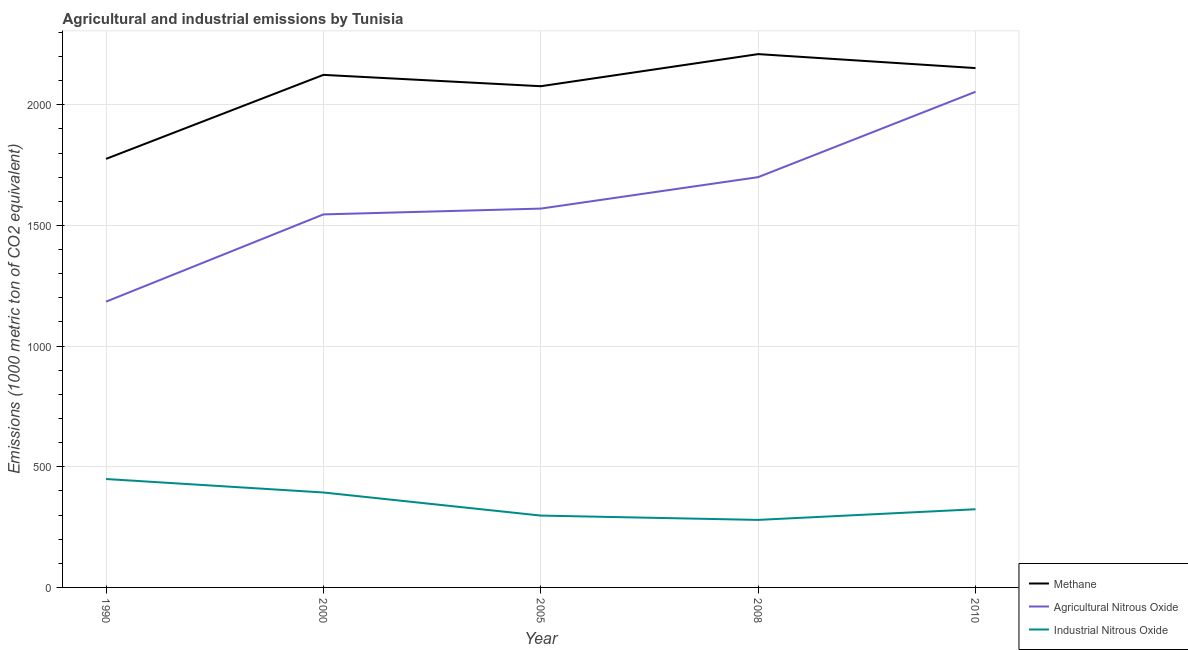How many different coloured lines are there?
Your response must be concise. 3. Is the number of lines equal to the number of legend labels?
Your response must be concise. Yes. What is the amount of agricultural nitrous oxide emissions in 2010?
Offer a terse response. 2053.7. Across all years, what is the maximum amount of industrial nitrous oxide emissions?
Your response must be concise. 449.2. Across all years, what is the minimum amount of methane emissions?
Your response must be concise. 1775.7. What is the total amount of industrial nitrous oxide emissions in the graph?
Give a very brief answer. 1744. What is the difference between the amount of industrial nitrous oxide emissions in 1990 and that in 2008?
Your answer should be very brief. 169.4. What is the difference between the amount of methane emissions in 2008 and the amount of industrial nitrous oxide emissions in 2005?
Make the answer very short. 1912.1. What is the average amount of agricultural nitrous oxide emissions per year?
Offer a terse response. 1610.62. In the year 2000, what is the difference between the amount of agricultural nitrous oxide emissions and amount of industrial nitrous oxide emissions?
Provide a short and direct response. 1152.2. In how many years, is the amount of methane emissions greater than 1400 metric ton?
Ensure brevity in your answer.  5. What is the ratio of the amount of industrial nitrous oxide emissions in 1990 to that in 2008?
Provide a short and direct response. 1.61. What is the difference between the highest and the second highest amount of agricultural nitrous oxide emissions?
Give a very brief answer. 353.7. What is the difference between the highest and the lowest amount of methane emissions?
Your response must be concise. 434.1. In how many years, is the amount of industrial nitrous oxide emissions greater than the average amount of industrial nitrous oxide emissions taken over all years?
Give a very brief answer. 2. Is it the case that in every year, the sum of the amount of methane emissions and amount of agricultural nitrous oxide emissions is greater than the amount of industrial nitrous oxide emissions?
Give a very brief answer. Yes. Does the amount of methane emissions monotonically increase over the years?
Make the answer very short. No. Is the amount of methane emissions strictly less than the amount of agricultural nitrous oxide emissions over the years?
Your answer should be very brief. No. What is the difference between two consecutive major ticks on the Y-axis?
Provide a succinct answer. 500. Does the graph contain grids?
Your answer should be compact. Yes. Where does the legend appear in the graph?
Keep it short and to the point. Bottom right. What is the title of the graph?
Offer a very short reply. Agricultural and industrial emissions by Tunisia. What is the label or title of the X-axis?
Your answer should be very brief. Year. What is the label or title of the Y-axis?
Provide a short and direct response. Emissions (1000 metric ton of CO2 equivalent). What is the Emissions (1000 metric ton of CO2 equivalent) of Methane in 1990?
Provide a short and direct response. 1775.7. What is the Emissions (1000 metric ton of CO2 equivalent) of Agricultural Nitrous Oxide in 1990?
Your answer should be very brief. 1184.1. What is the Emissions (1000 metric ton of CO2 equivalent) of Industrial Nitrous Oxide in 1990?
Provide a short and direct response. 449.2. What is the Emissions (1000 metric ton of CO2 equivalent) in Methane in 2000?
Make the answer very short. 2123.8. What is the Emissions (1000 metric ton of CO2 equivalent) in Agricultural Nitrous Oxide in 2000?
Your answer should be very brief. 1545.6. What is the Emissions (1000 metric ton of CO2 equivalent) in Industrial Nitrous Oxide in 2000?
Offer a very short reply. 393.4. What is the Emissions (1000 metric ton of CO2 equivalent) in Methane in 2005?
Your answer should be very brief. 2076.8. What is the Emissions (1000 metric ton of CO2 equivalent) in Agricultural Nitrous Oxide in 2005?
Offer a terse response. 1569.7. What is the Emissions (1000 metric ton of CO2 equivalent) in Industrial Nitrous Oxide in 2005?
Your answer should be very brief. 297.7. What is the Emissions (1000 metric ton of CO2 equivalent) of Methane in 2008?
Offer a very short reply. 2209.8. What is the Emissions (1000 metric ton of CO2 equivalent) of Agricultural Nitrous Oxide in 2008?
Your answer should be compact. 1700. What is the Emissions (1000 metric ton of CO2 equivalent) of Industrial Nitrous Oxide in 2008?
Give a very brief answer. 279.8. What is the Emissions (1000 metric ton of CO2 equivalent) of Methane in 2010?
Ensure brevity in your answer.  2151.9. What is the Emissions (1000 metric ton of CO2 equivalent) in Agricultural Nitrous Oxide in 2010?
Make the answer very short. 2053.7. What is the Emissions (1000 metric ton of CO2 equivalent) in Industrial Nitrous Oxide in 2010?
Make the answer very short. 323.9. Across all years, what is the maximum Emissions (1000 metric ton of CO2 equivalent) of Methane?
Your response must be concise. 2209.8. Across all years, what is the maximum Emissions (1000 metric ton of CO2 equivalent) of Agricultural Nitrous Oxide?
Make the answer very short. 2053.7. Across all years, what is the maximum Emissions (1000 metric ton of CO2 equivalent) in Industrial Nitrous Oxide?
Offer a terse response. 449.2. Across all years, what is the minimum Emissions (1000 metric ton of CO2 equivalent) of Methane?
Offer a terse response. 1775.7. Across all years, what is the minimum Emissions (1000 metric ton of CO2 equivalent) in Agricultural Nitrous Oxide?
Your answer should be compact. 1184.1. Across all years, what is the minimum Emissions (1000 metric ton of CO2 equivalent) in Industrial Nitrous Oxide?
Keep it short and to the point. 279.8. What is the total Emissions (1000 metric ton of CO2 equivalent) in Methane in the graph?
Ensure brevity in your answer.  1.03e+04. What is the total Emissions (1000 metric ton of CO2 equivalent) of Agricultural Nitrous Oxide in the graph?
Provide a short and direct response. 8053.1. What is the total Emissions (1000 metric ton of CO2 equivalent) in Industrial Nitrous Oxide in the graph?
Offer a very short reply. 1744. What is the difference between the Emissions (1000 metric ton of CO2 equivalent) in Methane in 1990 and that in 2000?
Your response must be concise. -348.1. What is the difference between the Emissions (1000 metric ton of CO2 equivalent) of Agricultural Nitrous Oxide in 1990 and that in 2000?
Your response must be concise. -361.5. What is the difference between the Emissions (1000 metric ton of CO2 equivalent) of Industrial Nitrous Oxide in 1990 and that in 2000?
Ensure brevity in your answer.  55.8. What is the difference between the Emissions (1000 metric ton of CO2 equivalent) of Methane in 1990 and that in 2005?
Give a very brief answer. -301.1. What is the difference between the Emissions (1000 metric ton of CO2 equivalent) in Agricultural Nitrous Oxide in 1990 and that in 2005?
Your answer should be compact. -385.6. What is the difference between the Emissions (1000 metric ton of CO2 equivalent) of Industrial Nitrous Oxide in 1990 and that in 2005?
Your answer should be very brief. 151.5. What is the difference between the Emissions (1000 metric ton of CO2 equivalent) in Methane in 1990 and that in 2008?
Your answer should be very brief. -434.1. What is the difference between the Emissions (1000 metric ton of CO2 equivalent) of Agricultural Nitrous Oxide in 1990 and that in 2008?
Give a very brief answer. -515.9. What is the difference between the Emissions (1000 metric ton of CO2 equivalent) of Industrial Nitrous Oxide in 1990 and that in 2008?
Keep it short and to the point. 169.4. What is the difference between the Emissions (1000 metric ton of CO2 equivalent) in Methane in 1990 and that in 2010?
Keep it short and to the point. -376.2. What is the difference between the Emissions (1000 metric ton of CO2 equivalent) in Agricultural Nitrous Oxide in 1990 and that in 2010?
Provide a short and direct response. -869.6. What is the difference between the Emissions (1000 metric ton of CO2 equivalent) in Industrial Nitrous Oxide in 1990 and that in 2010?
Your answer should be very brief. 125.3. What is the difference between the Emissions (1000 metric ton of CO2 equivalent) in Methane in 2000 and that in 2005?
Your response must be concise. 47. What is the difference between the Emissions (1000 metric ton of CO2 equivalent) in Agricultural Nitrous Oxide in 2000 and that in 2005?
Offer a very short reply. -24.1. What is the difference between the Emissions (1000 metric ton of CO2 equivalent) in Industrial Nitrous Oxide in 2000 and that in 2005?
Ensure brevity in your answer.  95.7. What is the difference between the Emissions (1000 metric ton of CO2 equivalent) in Methane in 2000 and that in 2008?
Ensure brevity in your answer.  -86. What is the difference between the Emissions (1000 metric ton of CO2 equivalent) in Agricultural Nitrous Oxide in 2000 and that in 2008?
Keep it short and to the point. -154.4. What is the difference between the Emissions (1000 metric ton of CO2 equivalent) in Industrial Nitrous Oxide in 2000 and that in 2008?
Your response must be concise. 113.6. What is the difference between the Emissions (1000 metric ton of CO2 equivalent) of Methane in 2000 and that in 2010?
Give a very brief answer. -28.1. What is the difference between the Emissions (1000 metric ton of CO2 equivalent) in Agricultural Nitrous Oxide in 2000 and that in 2010?
Give a very brief answer. -508.1. What is the difference between the Emissions (1000 metric ton of CO2 equivalent) of Industrial Nitrous Oxide in 2000 and that in 2010?
Make the answer very short. 69.5. What is the difference between the Emissions (1000 metric ton of CO2 equivalent) in Methane in 2005 and that in 2008?
Your response must be concise. -133. What is the difference between the Emissions (1000 metric ton of CO2 equivalent) of Agricultural Nitrous Oxide in 2005 and that in 2008?
Your response must be concise. -130.3. What is the difference between the Emissions (1000 metric ton of CO2 equivalent) of Industrial Nitrous Oxide in 2005 and that in 2008?
Your answer should be compact. 17.9. What is the difference between the Emissions (1000 metric ton of CO2 equivalent) in Methane in 2005 and that in 2010?
Keep it short and to the point. -75.1. What is the difference between the Emissions (1000 metric ton of CO2 equivalent) of Agricultural Nitrous Oxide in 2005 and that in 2010?
Keep it short and to the point. -484. What is the difference between the Emissions (1000 metric ton of CO2 equivalent) of Industrial Nitrous Oxide in 2005 and that in 2010?
Keep it short and to the point. -26.2. What is the difference between the Emissions (1000 metric ton of CO2 equivalent) in Methane in 2008 and that in 2010?
Keep it short and to the point. 57.9. What is the difference between the Emissions (1000 metric ton of CO2 equivalent) of Agricultural Nitrous Oxide in 2008 and that in 2010?
Keep it short and to the point. -353.7. What is the difference between the Emissions (1000 metric ton of CO2 equivalent) of Industrial Nitrous Oxide in 2008 and that in 2010?
Provide a short and direct response. -44.1. What is the difference between the Emissions (1000 metric ton of CO2 equivalent) of Methane in 1990 and the Emissions (1000 metric ton of CO2 equivalent) of Agricultural Nitrous Oxide in 2000?
Give a very brief answer. 230.1. What is the difference between the Emissions (1000 metric ton of CO2 equivalent) of Methane in 1990 and the Emissions (1000 metric ton of CO2 equivalent) of Industrial Nitrous Oxide in 2000?
Offer a terse response. 1382.3. What is the difference between the Emissions (1000 metric ton of CO2 equivalent) in Agricultural Nitrous Oxide in 1990 and the Emissions (1000 metric ton of CO2 equivalent) in Industrial Nitrous Oxide in 2000?
Your response must be concise. 790.7. What is the difference between the Emissions (1000 metric ton of CO2 equivalent) in Methane in 1990 and the Emissions (1000 metric ton of CO2 equivalent) in Agricultural Nitrous Oxide in 2005?
Your answer should be compact. 206. What is the difference between the Emissions (1000 metric ton of CO2 equivalent) in Methane in 1990 and the Emissions (1000 metric ton of CO2 equivalent) in Industrial Nitrous Oxide in 2005?
Ensure brevity in your answer.  1478. What is the difference between the Emissions (1000 metric ton of CO2 equivalent) of Agricultural Nitrous Oxide in 1990 and the Emissions (1000 metric ton of CO2 equivalent) of Industrial Nitrous Oxide in 2005?
Offer a terse response. 886.4. What is the difference between the Emissions (1000 metric ton of CO2 equivalent) of Methane in 1990 and the Emissions (1000 metric ton of CO2 equivalent) of Agricultural Nitrous Oxide in 2008?
Ensure brevity in your answer.  75.7. What is the difference between the Emissions (1000 metric ton of CO2 equivalent) of Methane in 1990 and the Emissions (1000 metric ton of CO2 equivalent) of Industrial Nitrous Oxide in 2008?
Provide a succinct answer. 1495.9. What is the difference between the Emissions (1000 metric ton of CO2 equivalent) in Agricultural Nitrous Oxide in 1990 and the Emissions (1000 metric ton of CO2 equivalent) in Industrial Nitrous Oxide in 2008?
Your answer should be compact. 904.3. What is the difference between the Emissions (1000 metric ton of CO2 equivalent) of Methane in 1990 and the Emissions (1000 metric ton of CO2 equivalent) of Agricultural Nitrous Oxide in 2010?
Make the answer very short. -278. What is the difference between the Emissions (1000 metric ton of CO2 equivalent) in Methane in 1990 and the Emissions (1000 metric ton of CO2 equivalent) in Industrial Nitrous Oxide in 2010?
Offer a very short reply. 1451.8. What is the difference between the Emissions (1000 metric ton of CO2 equivalent) of Agricultural Nitrous Oxide in 1990 and the Emissions (1000 metric ton of CO2 equivalent) of Industrial Nitrous Oxide in 2010?
Provide a short and direct response. 860.2. What is the difference between the Emissions (1000 metric ton of CO2 equivalent) of Methane in 2000 and the Emissions (1000 metric ton of CO2 equivalent) of Agricultural Nitrous Oxide in 2005?
Your response must be concise. 554.1. What is the difference between the Emissions (1000 metric ton of CO2 equivalent) of Methane in 2000 and the Emissions (1000 metric ton of CO2 equivalent) of Industrial Nitrous Oxide in 2005?
Your response must be concise. 1826.1. What is the difference between the Emissions (1000 metric ton of CO2 equivalent) in Agricultural Nitrous Oxide in 2000 and the Emissions (1000 metric ton of CO2 equivalent) in Industrial Nitrous Oxide in 2005?
Offer a very short reply. 1247.9. What is the difference between the Emissions (1000 metric ton of CO2 equivalent) of Methane in 2000 and the Emissions (1000 metric ton of CO2 equivalent) of Agricultural Nitrous Oxide in 2008?
Your response must be concise. 423.8. What is the difference between the Emissions (1000 metric ton of CO2 equivalent) of Methane in 2000 and the Emissions (1000 metric ton of CO2 equivalent) of Industrial Nitrous Oxide in 2008?
Keep it short and to the point. 1844. What is the difference between the Emissions (1000 metric ton of CO2 equivalent) in Agricultural Nitrous Oxide in 2000 and the Emissions (1000 metric ton of CO2 equivalent) in Industrial Nitrous Oxide in 2008?
Provide a short and direct response. 1265.8. What is the difference between the Emissions (1000 metric ton of CO2 equivalent) of Methane in 2000 and the Emissions (1000 metric ton of CO2 equivalent) of Agricultural Nitrous Oxide in 2010?
Keep it short and to the point. 70.1. What is the difference between the Emissions (1000 metric ton of CO2 equivalent) in Methane in 2000 and the Emissions (1000 metric ton of CO2 equivalent) in Industrial Nitrous Oxide in 2010?
Provide a short and direct response. 1799.9. What is the difference between the Emissions (1000 metric ton of CO2 equivalent) in Agricultural Nitrous Oxide in 2000 and the Emissions (1000 metric ton of CO2 equivalent) in Industrial Nitrous Oxide in 2010?
Provide a succinct answer. 1221.7. What is the difference between the Emissions (1000 metric ton of CO2 equivalent) of Methane in 2005 and the Emissions (1000 metric ton of CO2 equivalent) of Agricultural Nitrous Oxide in 2008?
Provide a short and direct response. 376.8. What is the difference between the Emissions (1000 metric ton of CO2 equivalent) in Methane in 2005 and the Emissions (1000 metric ton of CO2 equivalent) in Industrial Nitrous Oxide in 2008?
Make the answer very short. 1797. What is the difference between the Emissions (1000 metric ton of CO2 equivalent) in Agricultural Nitrous Oxide in 2005 and the Emissions (1000 metric ton of CO2 equivalent) in Industrial Nitrous Oxide in 2008?
Your answer should be compact. 1289.9. What is the difference between the Emissions (1000 metric ton of CO2 equivalent) in Methane in 2005 and the Emissions (1000 metric ton of CO2 equivalent) in Agricultural Nitrous Oxide in 2010?
Make the answer very short. 23.1. What is the difference between the Emissions (1000 metric ton of CO2 equivalent) of Methane in 2005 and the Emissions (1000 metric ton of CO2 equivalent) of Industrial Nitrous Oxide in 2010?
Give a very brief answer. 1752.9. What is the difference between the Emissions (1000 metric ton of CO2 equivalent) in Agricultural Nitrous Oxide in 2005 and the Emissions (1000 metric ton of CO2 equivalent) in Industrial Nitrous Oxide in 2010?
Offer a very short reply. 1245.8. What is the difference between the Emissions (1000 metric ton of CO2 equivalent) of Methane in 2008 and the Emissions (1000 metric ton of CO2 equivalent) of Agricultural Nitrous Oxide in 2010?
Give a very brief answer. 156.1. What is the difference between the Emissions (1000 metric ton of CO2 equivalent) of Methane in 2008 and the Emissions (1000 metric ton of CO2 equivalent) of Industrial Nitrous Oxide in 2010?
Keep it short and to the point. 1885.9. What is the difference between the Emissions (1000 metric ton of CO2 equivalent) of Agricultural Nitrous Oxide in 2008 and the Emissions (1000 metric ton of CO2 equivalent) of Industrial Nitrous Oxide in 2010?
Ensure brevity in your answer.  1376.1. What is the average Emissions (1000 metric ton of CO2 equivalent) of Methane per year?
Provide a succinct answer. 2067.6. What is the average Emissions (1000 metric ton of CO2 equivalent) of Agricultural Nitrous Oxide per year?
Ensure brevity in your answer.  1610.62. What is the average Emissions (1000 metric ton of CO2 equivalent) in Industrial Nitrous Oxide per year?
Offer a very short reply. 348.8. In the year 1990, what is the difference between the Emissions (1000 metric ton of CO2 equivalent) in Methane and Emissions (1000 metric ton of CO2 equivalent) in Agricultural Nitrous Oxide?
Your response must be concise. 591.6. In the year 1990, what is the difference between the Emissions (1000 metric ton of CO2 equivalent) in Methane and Emissions (1000 metric ton of CO2 equivalent) in Industrial Nitrous Oxide?
Your answer should be very brief. 1326.5. In the year 1990, what is the difference between the Emissions (1000 metric ton of CO2 equivalent) of Agricultural Nitrous Oxide and Emissions (1000 metric ton of CO2 equivalent) of Industrial Nitrous Oxide?
Your response must be concise. 734.9. In the year 2000, what is the difference between the Emissions (1000 metric ton of CO2 equivalent) of Methane and Emissions (1000 metric ton of CO2 equivalent) of Agricultural Nitrous Oxide?
Make the answer very short. 578.2. In the year 2000, what is the difference between the Emissions (1000 metric ton of CO2 equivalent) in Methane and Emissions (1000 metric ton of CO2 equivalent) in Industrial Nitrous Oxide?
Your answer should be compact. 1730.4. In the year 2000, what is the difference between the Emissions (1000 metric ton of CO2 equivalent) in Agricultural Nitrous Oxide and Emissions (1000 metric ton of CO2 equivalent) in Industrial Nitrous Oxide?
Ensure brevity in your answer.  1152.2. In the year 2005, what is the difference between the Emissions (1000 metric ton of CO2 equivalent) in Methane and Emissions (1000 metric ton of CO2 equivalent) in Agricultural Nitrous Oxide?
Provide a succinct answer. 507.1. In the year 2005, what is the difference between the Emissions (1000 metric ton of CO2 equivalent) in Methane and Emissions (1000 metric ton of CO2 equivalent) in Industrial Nitrous Oxide?
Keep it short and to the point. 1779.1. In the year 2005, what is the difference between the Emissions (1000 metric ton of CO2 equivalent) of Agricultural Nitrous Oxide and Emissions (1000 metric ton of CO2 equivalent) of Industrial Nitrous Oxide?
Offer a very short reply. 1272. In the year 2008, what is the difference between the Emissions (1000 metric ton of CO2 equivalent) in Methane and Emissions (1000 metric ton of CO2 equivalent) in Agricultural Nitrous Oxide?
Your answer should be very brief. 509.8. In the year 2008, what is the difference between the Emissions (1000 metric ton of CO2 equivalent) in Methane and Emissions (1000 metric ton of CO2 equivalent) in Industrial Nitrous Oxide?
Offer a terse response. 1930. In the year 2008, what is the difference between the Emissions (1000 metric ton of CO2 equivalent) of Agricultural Nitrous Oxide and Emissions (1000 metric ton of CO2 equivalent) of Industrial Nitrous Oxide?
Provide a short and direct response. 1420.2. In the year 2010, what is the difference between the Emissions (1000 metric ton of CO2 equivalent) in Methane and Emissions (1000 metric ton of CO2 equivalent) in Agricultural Nitrous Oxide?
Make the answer very short. 98.2. In the year 2010, what is the difference between the Emissions (1000 metric ton of CO2 equivalent) of Methane and Emissions (1000 metric ton of CO2 equivalent) of Industrial Nitrous Oxide?
Give a very brief answer. 1828. In the year 2010, what is the difference between the Emissions (1000 metric ton of CO2 equivalent) in Agricultural Nitrous Oxide and Emissions (1000 metric ton of CO2 equivalent) in Industrial Nitrous Oxide?
Provide a succinct answer. 1729.8. What is the ratio of the Emissions (1000 metric ton of CO2 equivalent) of Methane in 1990 to that in 2000?
Make the answer very short. 0.84. What is the ratio of the Emissions (1000 metric ton of CO2 equivalent) of Agricultural Nitrous Oxide in 1990 to that in 2000?
Your response must be concise. 0.77. What is the ratio of the Emissions (1000 metric ton of CO2 equivalent) of Industrial Nitrous Oxide in 1990 to that in 2000?
Give a very brief answer. 1.14. What is the ratio of the Emissions (1000 metric ton of CO2 equivalent) in Methane in 1990 to that in 2005?
Your answer should be compact. 0.85. What is the ratio of the Emissions (1000 metric ton of CO2 equivalent) of Agricultural Nitrous Oxide in 1990 to that in 2005?
Offer a very short reply. 0.75. What is the ratio of the Emissions (1000 metric ton of CO2 equivalent) in Industrial Nitrous Oxide in 1990 to that in 2005?
Your answer should be very brief. 1.51. What is the ratio of the Emissions (1000 metric ton of CO2 equivalent) of Methane in 1990 to that in 2008?
Give a very brief answer. 0.8. What is the ratio of the Emissions (1000 metric ton of CO2 equivalent) of Agricultural Nitrous Oxide in 1990 to that in 2008?
Your response must be concise. 0.7. What is the ratio of the Emissions (1000 metric ton of CO2 equivalent) in Industrial Nitrous Oxide in 1990 to that in 2008?
Provide a succinct answer. 1.61. What is the ratio of the Emissions (1000 metric ton of CO2 equivalent) in Methane in 1990 to that in 2010?
Provide a succinct answer. 0.83. What is the ratio of the Emissions (1000 metric ton of CO2 equivalent) of Agricultural Nitrous Oxide in 1990 to that in 2010?
Offer a very short reply. 0.58. What is the ratio of the Emissions (1000 metric ton of CO2 equivalent) in Industrial Nitrous Oxide in 1990 to that in 2010?
Keep it short and to the point. 1.39. What is the ratio of the Emissions (1000 metric ton of CO2 equivalent) of Methane in 2000 to that in 2005?
Your answer should be very brief. 1.02. What is the ratio of the Emissions (1000 metric ton of CO2 equivalent) of Agricultural Nitrous Oxide in 2000 to that in 2005?
Offer a terse response. 0.98. What is the ratio of the Emissions (1000 metric ton of CO2 equivalent) in Industrial Nitrous Oxide in 2000 to that in 2005?
Provide a short and direct response. 1.32. What is the ratio of the Emissions (1000 metric ton of CO2 equivalent) of Methane in 2000 to that in 2008?
Ensure brevity in your answer.  0.96. What is the ratio of the Emissions (1000 metric ton of CO2 equivalent) of Agricultural Nitrous Oxide in 2000 to that in 2008?
Your response must be concise. 0.91. What is the ratio of the Emissions (1000 metric ton of CO2 equivalent) in Industrial Nitrous Oxide in 2000 to that in 2008?
Your response must be concise. 1.41. What is the ratio of the Emissions (1000 metric ton of CO2 equivalent) of Methane in 2000 to that in 2010?
Provide a succinct answer. 0.99. What is the ratio of the Emissions (1000 metric ton of CO2 equivalent) of Agricultural Nitrous Oxide in 2000 to that in 2010?
Keep it short and to the point. 0.75. What is the ratio of the Emissions (1000 metric ton of CO2 equivalent) in Industrial Nitrous Oxide in 2000 to that in 2010?
Offer a terse response. 1.21. What is the ratio of the Emissions (1000 metric ton of CO2 equivalent) of Methane in 2005 to that in 2008?
Your answer should be compact. 0.94. What is the ratio of the Emissions (1000 metric ton of CO2 equivalent) of Agricultural Nitrous Oxide in 2005 to that in 2008?
Your response must be concise. 0.92. What is the ratio of the Emissions (1000 metric ton of CO2 equivalent) in Industrial Nitrous Oxide in 2005 to that in 2008?
Your answer should be compact. 1.06. What is the ratio of the Emissions (1000 metric ton of CO2 equivalent) in Methane in 2005 to that in 2010?
Your answer should be compact. 0.97. What is the ratio of the Emissions (1000 metric ton of CO2 equivalent) in Agricultural Nitrous Oxide in 2005 to that in 2010?
Offer a terse response. 0.76. What is the ratio of the Emissions (1000 metric ton of CO2 equivalent) in Industrial Nitrous Oxide in 2005 to that in 2010?
Your answer should be very brief. 0.92. What is the ratio of the Emissions (1000 metric ton of CO2 equivalent) in Methane in 2008 to that in 2010?
Offer a very short reply. 1.03. What is the ratio of the Emissions (1000 metric ton of CO2 equivalent) of Agricultural Nitrous Oxide in 2008 to that in 2010?
Your response must be concise. 0.83. What is the ratio of the Emissions (1000 metric ton of CO2 equivalent) of Industrial Nitrous Oxide in 2008 to that in 2010?
Keep it short and to the point. 0.86. What is the difference between the highest and the second highest Emissions (1000 metric ton of CO2 equivalent) in Methane?
Keep it short and to the point. 57.9. What is the difference between the highest and the second highest Emissions (1000 metric ton of CO2 equivalent) in Agricultural Nitrous Oxide?
Provide a short and direct response. 353.7. What is the difference between the highest and the second highest Emissions (1000 metric ton of CO2 equivalent) in Industrial Nitrous Oxide?
Offer a very short reply. 55.8. What is the difference between the highest and the lowest Emissions (1000 metric ton of CO2 equivalent) of Methane?
Make the answer very short. 434.1. What is the difference between the highest and the lowest Emissions (1000 metric ton of CO2 equivalent) in Agricultural Nitrous Oxide?
Your answer should be compact. 869.6. What is the difference between the highest and the lowest Emissions (1000 metric ton of CO2 equivalent) of Industrial Nitrous Oxide?
Make the answer very short. 169.4. 